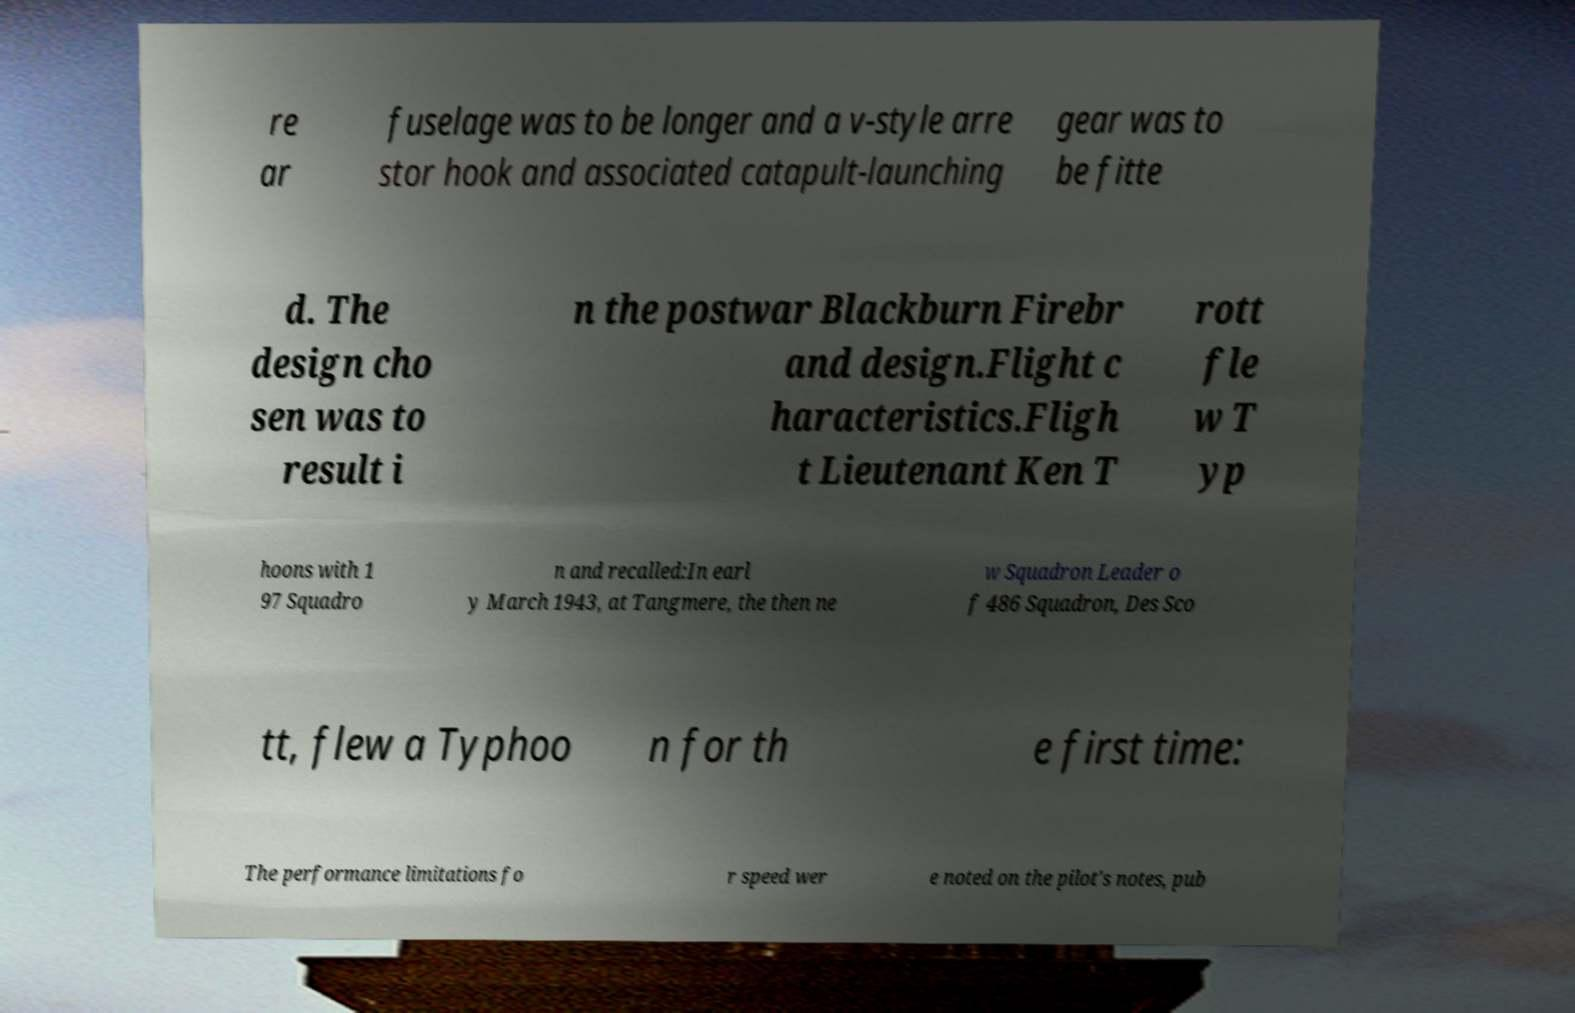Please read and relay the text visible in this image. What does it say? re ar fuselage was to be longer and a v-style arre stor hook and associated catapult-launching gear was to be fitte d. The design cho sen was to result i n the postwar Blackburn Firebr and design.Flight c haracteristics.Fligh t Lieutenant Ken T rott fle w T yp hoons with 1 97 Squadro n and recalled:In earl y March 1943, at Tangmere, the then ne w Squadron Leader o f 486 Squadron, Des Sco tt, flew a Typhoo n for th e first time: The performance limitations fo r speed wer e noted on the pilot's notes, pub 